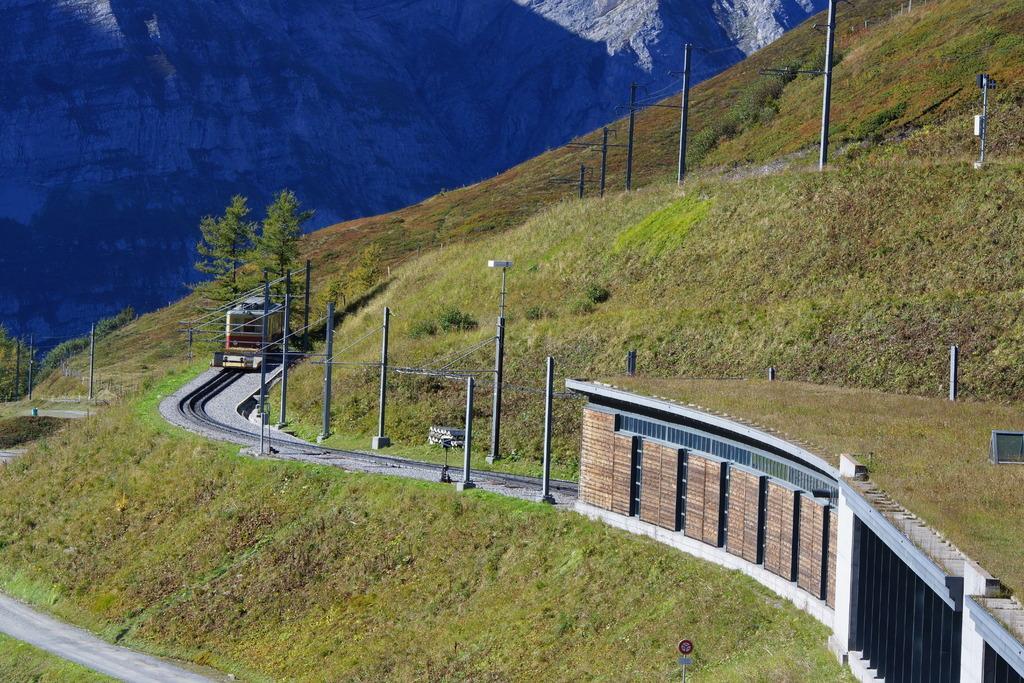In one or two sentences, can you explain what this image depicts? This is an outside view. On the ground, I can see the grass. On the left side there is a train on the railway track. On the right side there is a tunnel. On both sides of the track there are many poles. On the left side there are trees. In the background there are mountains. 